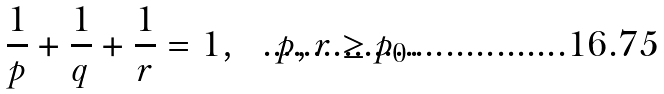Convert formula to latex. <formula><loc_0><loc_0><loc_500><loc_500>\frac { 1 } { p } + \frac { 1 } { q } + \frac { 1 } { r } = 1 , \quad p , r \geq p _ { 0 } .</formula> 